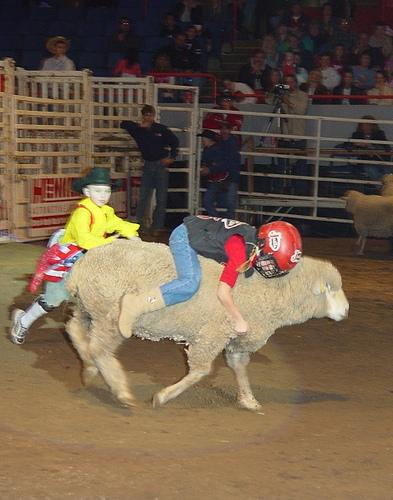Why are the little people riding the sheep? Please explain your reasoning. are children. The kids are children competing in a mutton busting contest. 